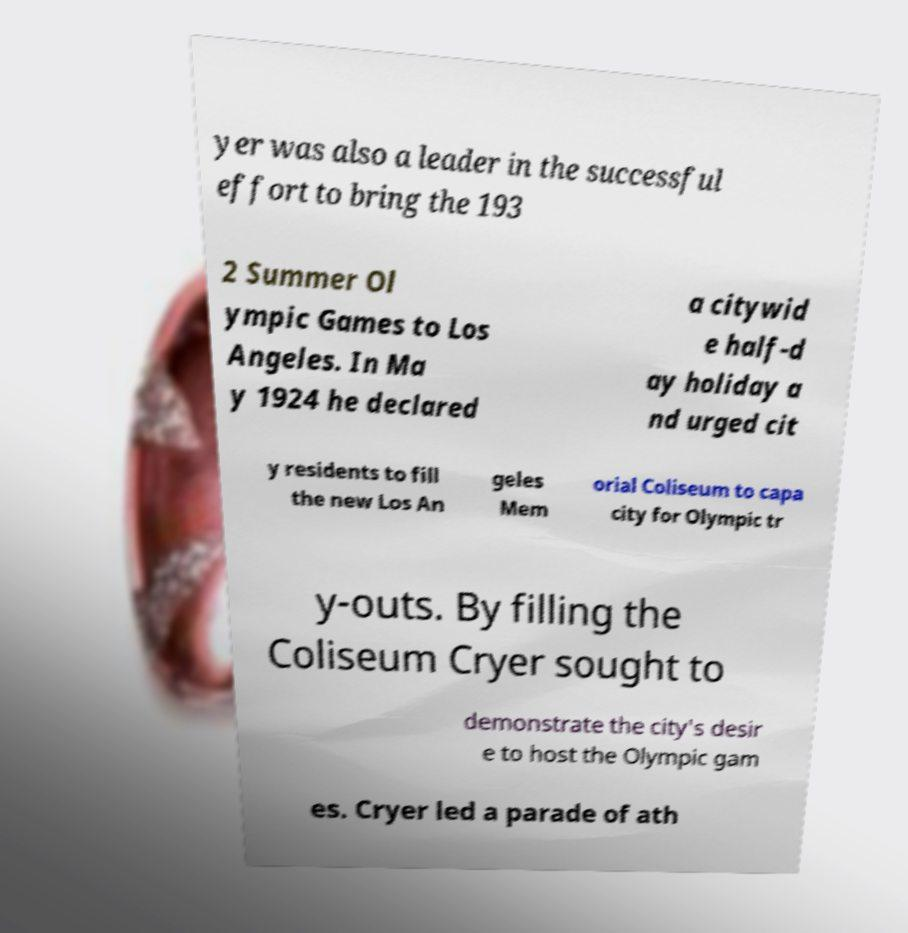Could you extract and type out the text from this image? yer was also a leader in the successful effort to bring the 193 2 Summer Ol ympic Games to Los Angeles. In Ma y 1924 he declared a citywid e half-d ay holiday a nd urged cit y residents to fill the new Los An geles Mem orial Coliseum to capa city for Olympic tr y-outs. By filling the Coliseum Cryer sought to demonstrate the city's desir e to host the Olympic gam es. Cryer led a parade of ath 